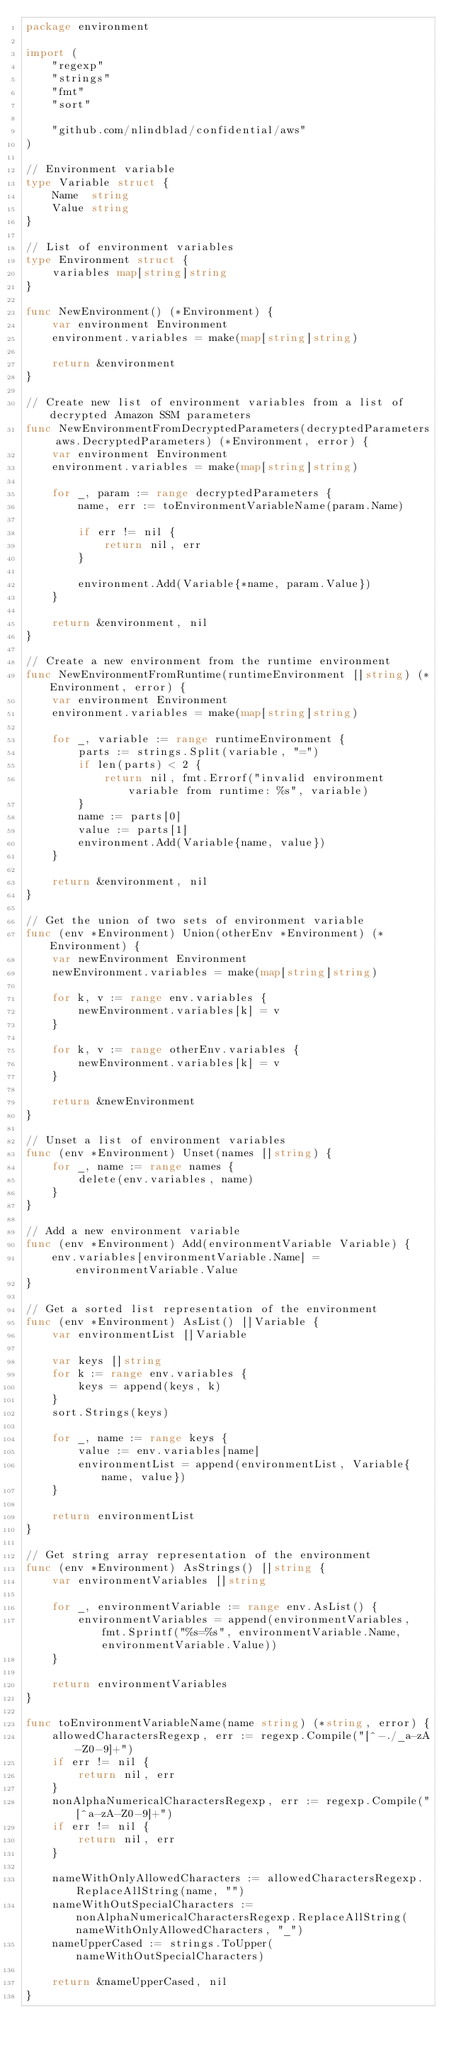Convert code to text. <code><loc_0><loc_0><loc_500><loc_500><_Go_>package environment

import (
	"regexp"
	"strings"
	"fmt"
	"sort"

	"github.com/nlindblad/confidential/aws"
)

// Environment variable
type Variable struct {
	Name  string
	Value string
}

// List of environment variables
type Environment struct {
	variables map[string]string
}

func NewEnvironment() (*Environment) {
	var environment Environment
	environment.variables = make(map[string]string)

	return &environment
}

// Create new list of environment variables from a list of decrypted Amazon SSM parameters
func NewEnvironmentFromDecryptedParameters(decryptedParameters aws.DecryptedParameters) (*Environment, error) {
	var environment Environment
	environment.variables = make(map[string]string)

	for _, param := range decryptedParameters {
		name, err := toEnvironmentVariableName(param.Name)

		if err != nil {
			return nil, err
		}

		environment.Add(Variable{*name, param.Value})
	}

	return &environment, nil
}

// Create a new environment from the runtime environment
func NewEnvironmentFromRuntime(runtimeEnvironment []string) (*Environment, error) {
	var environment Environment
	environment.variables = make(map[string]string)

	for _, variable := range runtimeEnvironment {
		parts := strings.Split(variable, "=")
		if len(parts) < 2 {
			return nil, fmt.Errorf("invalid environment variable from runtime: %s", variable)
		}
		name := parts[0]
		value := parts[1]
		environment.Add(Variable{name, value})
	}

	return &environment, nil
}

// Get the union of two sets of environment variable
func (env *Environment) Union(otherEnv *Environment) (*Environment) {
	var newEnvironment Environment
	newEnvironment.variables = make(map[string]string)

	for k, v := range env.variables {
		newEnvironment.variables[k] = v
	}

	for k, v := range otherEnv.variables {
		newEnvironment.variables[k] = v
	}

	return &newEnvironment
}

// Unset a list of environment variables
func (env *Environment) Unset(names []string) {
	for _, name := range names {
		delete(env.variables, name)
	}
}

// Add a new environment variable
func (env *Environment) Add(environmentVariable Variable) {
	env.variables[environmentVariable.Name] = environmentVariable.Value
}

// Get a sorted list representation of the environment
func (env *Environment) AsList() []Variable {
	var environmentList []Variable

	var keys []string
	for k := range env.variables {
		keys = append(keys, k)
	}
	sort.Strings(keys)

	for _, name := range keys {
		value := env.variables[name]
		environmentList = append(environmentList, Variable{name, value})
	}

	return environmentList
}

// Get string array representation of the environment
func (env *Environment) AsStrings() []string {
	var environmentVariables []string

	for _, environmentVariable := range env.AsList() {
		environmentVariables = append(environmentVariables, fmt.Sprintf("%s=%s", environmentVariable.Name, environmentVariable.Value))
	}

	return environmentVariables
}

func toEnvironmentVariableName(name string) (*string, error) {
	allowedCharactersRegexp, err := regexp.Compile("[^-./_a-zA-Z0-9]+")
	if err != nil {
		return nil, err
	}
	nonAlphaNumericalCharactersRegexp, err := regexp.Compile("[^a-zA-Z0-9]+")
	if err != nil {
		return nil, err
	}

	nameWithOnlyAllowedCharacters := allowedCharactersRegexp.ReplaceAllString(name, "")
	nameWithOutSpecialCharacters := nonAlphaNumericalCharactersRegexp.ReplaceAllString(nameWithOnlyAllowedCharacters, "_")
	nameUpperCased := strings.ToUpper(nameWithOutSpecialCharacters)

	return &nameUpperCased, nil
}
</code> 